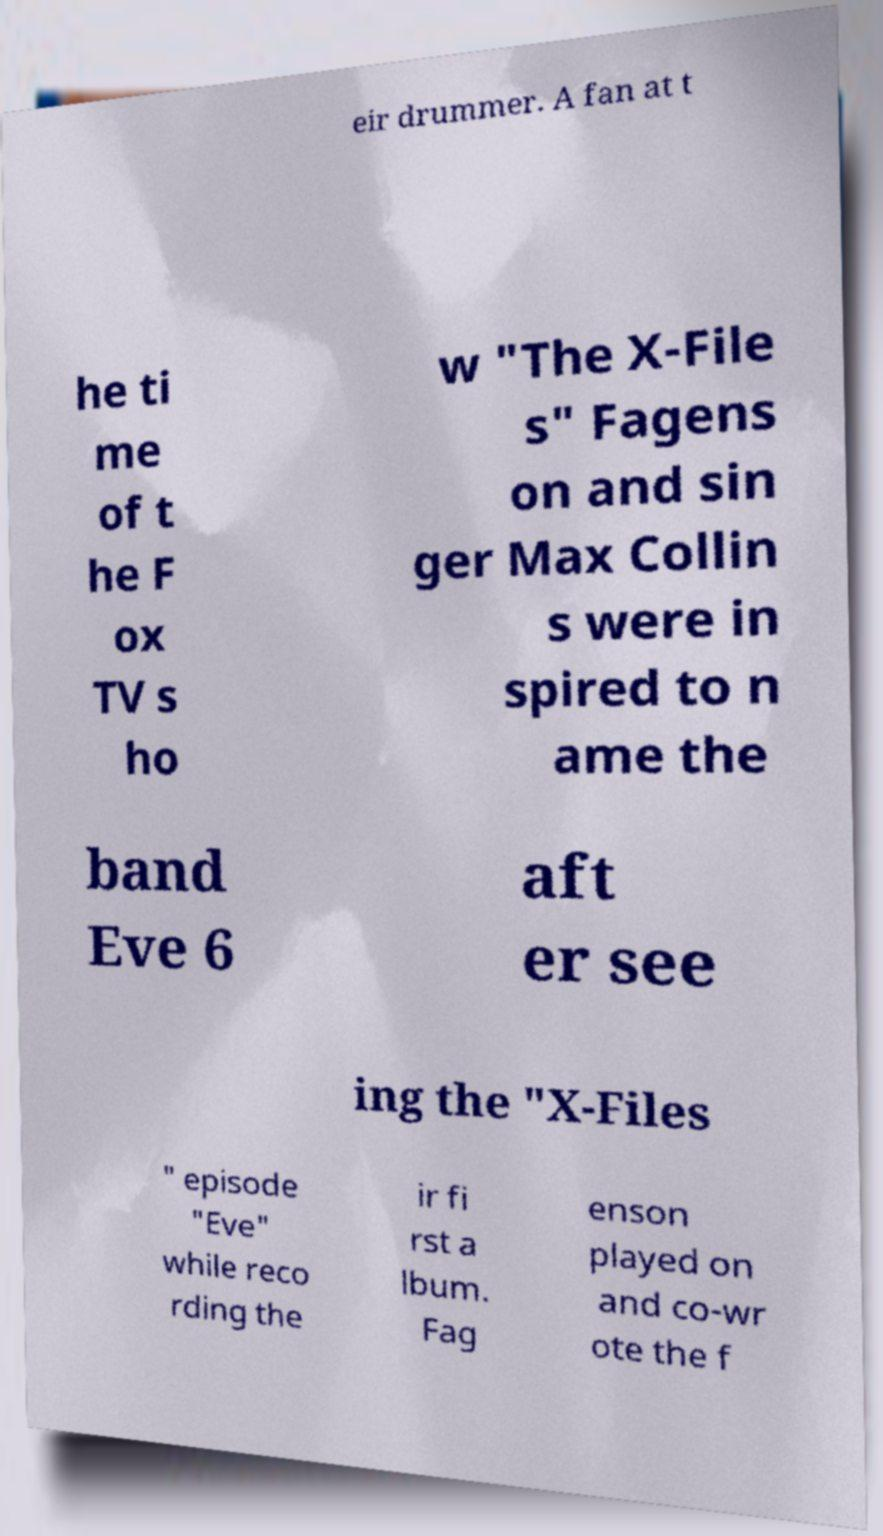Can you accurately transcribe the text from the provided image for me? eir drummer. A fan at t he ti me of t he F ox TV s ho w "The X-File s" Fagens on and sin ger Max Collin s were in spired to n ame the band Eve 6 aft er see ing the "X-Files " episode "Eve" while reco rding the ir fi rst a lbum. Fag enson played on and co-wr ote the f 